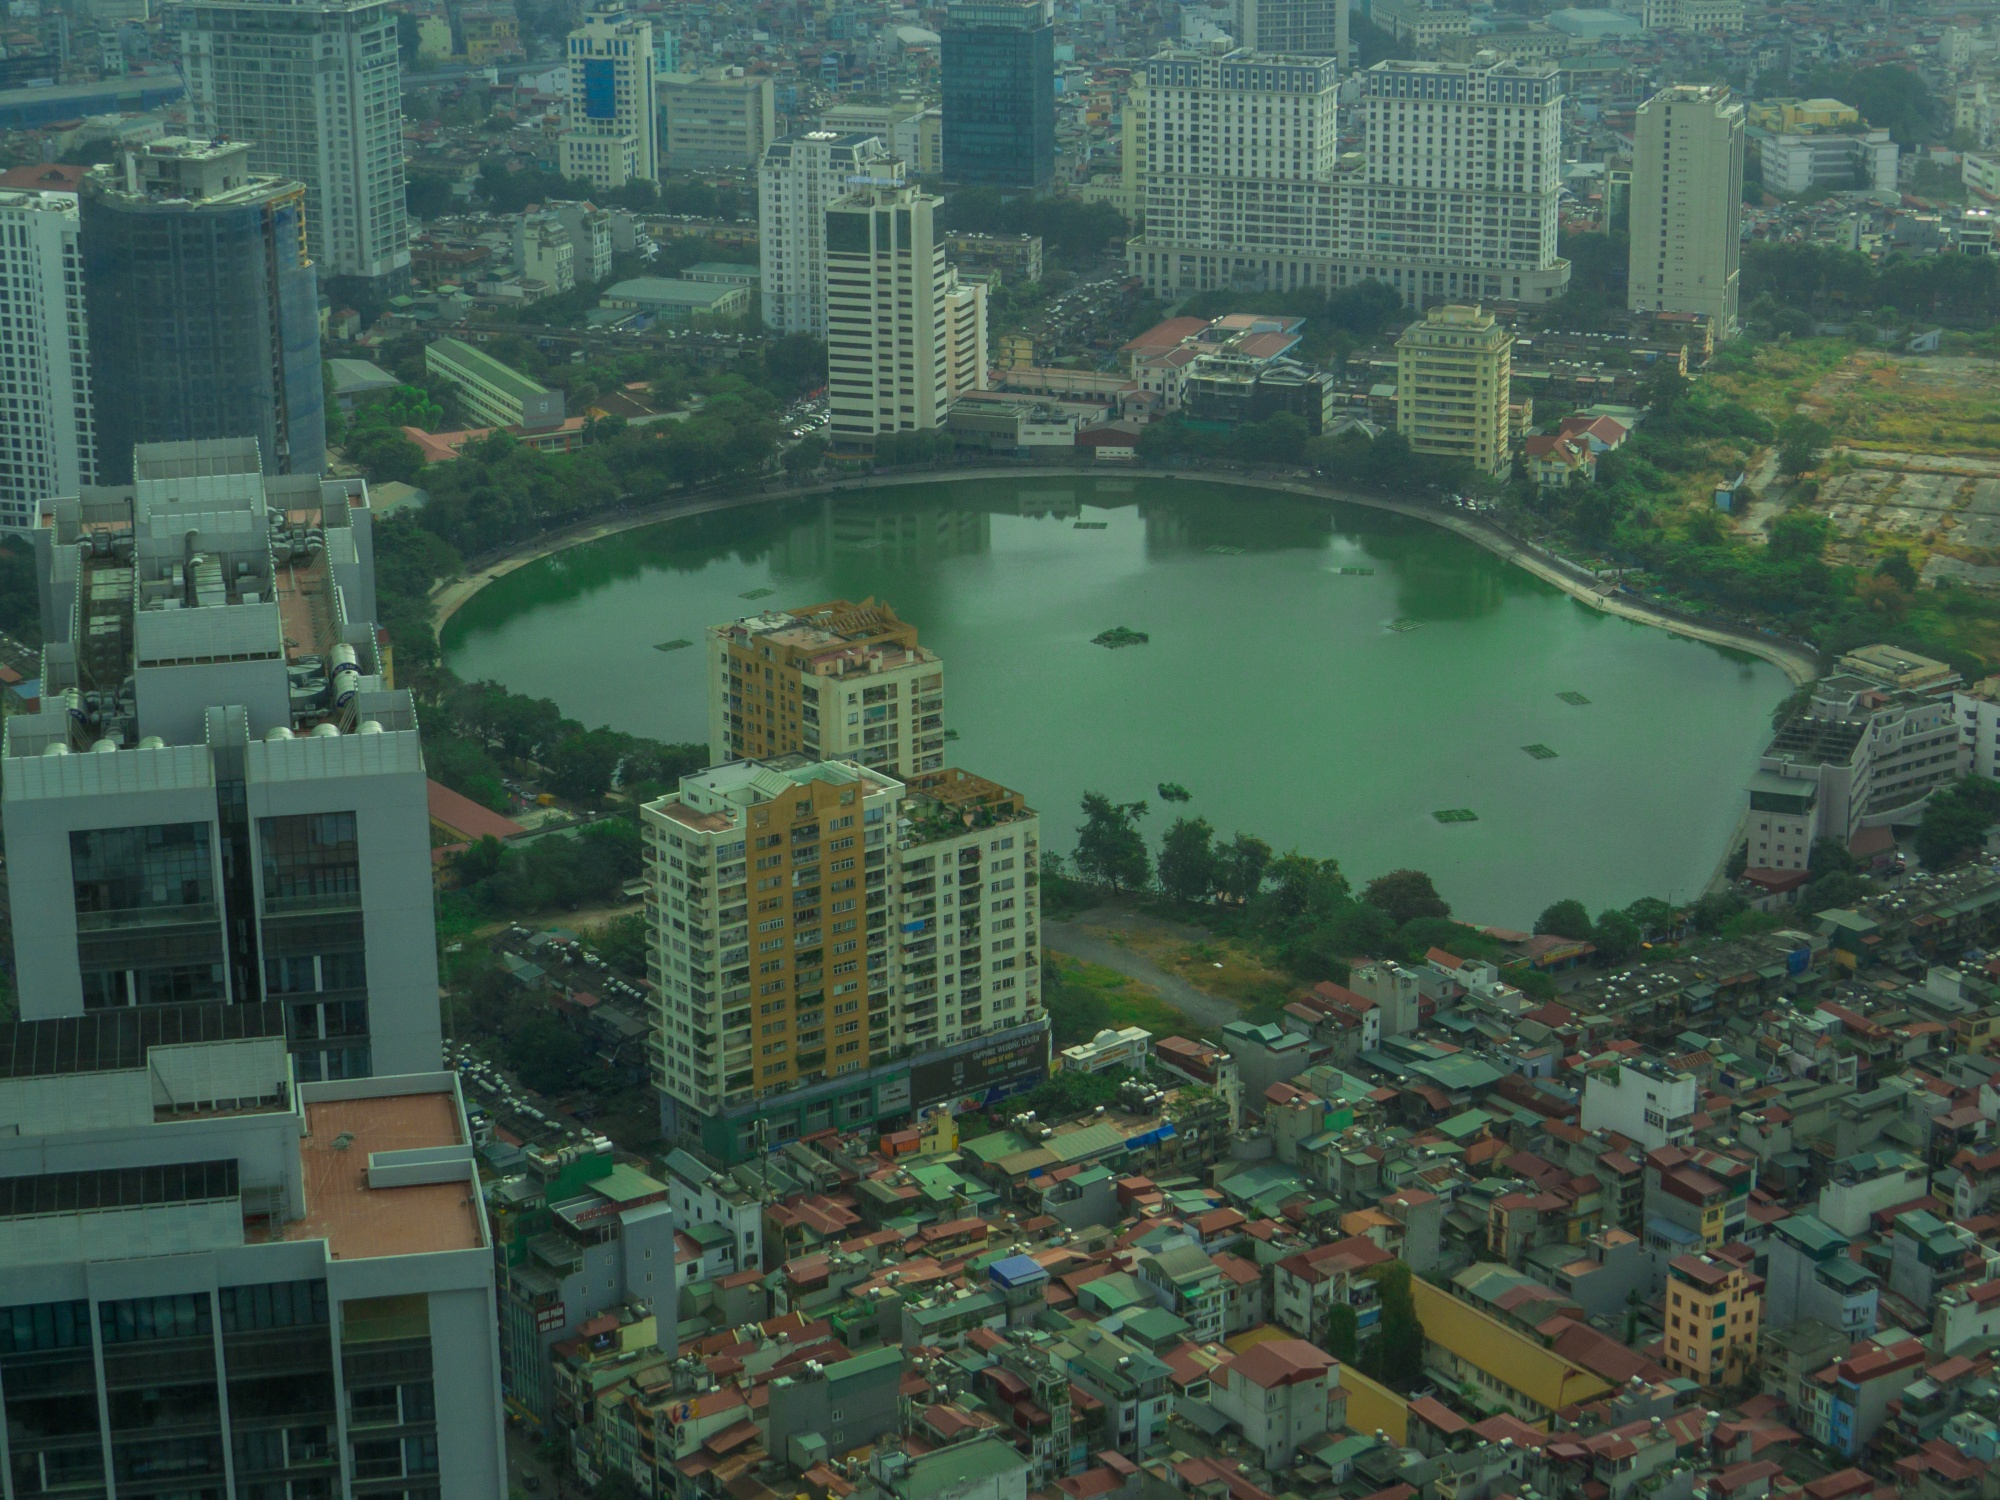Can you describe the historical significance and cultural relevance of this lake within the city? This lake has historically been a central gathering point for the city's inhabitants. Its origins trace back to ancient times when it served as a crucial source of water for agricultural and domestic use. Over centuries, it has evolved into a recreational and cultural landmark. Festivals, community events, and traditional ceremonies often take place by its shores, infusing the area with vibrant life and cultural heritage. The architecture around the lake displays a fascinating timeline - older buildings that tell tales of the past stand gracefully alongside modern structures, creating a tangible link between history and progress. Such a lake represents resilience and continuity, playing a significant role in the city's identity and day-to-day life. What kind of activities do people usually engage in around this lake? The lake is a hub of activity and serves multiple recreational purposes for the city’s residents. Strolling or jogging along the lakeside path is a popular activity, especially in the mornings and evenings. Families and friends gather for picnics and social outings on weekends, enjoying the scenic beauty and tranquil ambiance. On any given day, you might see children flying kites, couples boating on the calm waters, or street performers captivating audiences with their acts. The lakeside cafes and eateries are often bustling with customers savoring local delicacies while soaking in the view. During festivals, the lake becomes a focal point for large celebrations with music, dance, and colorful displays, making it a cherished social and cultural space. 